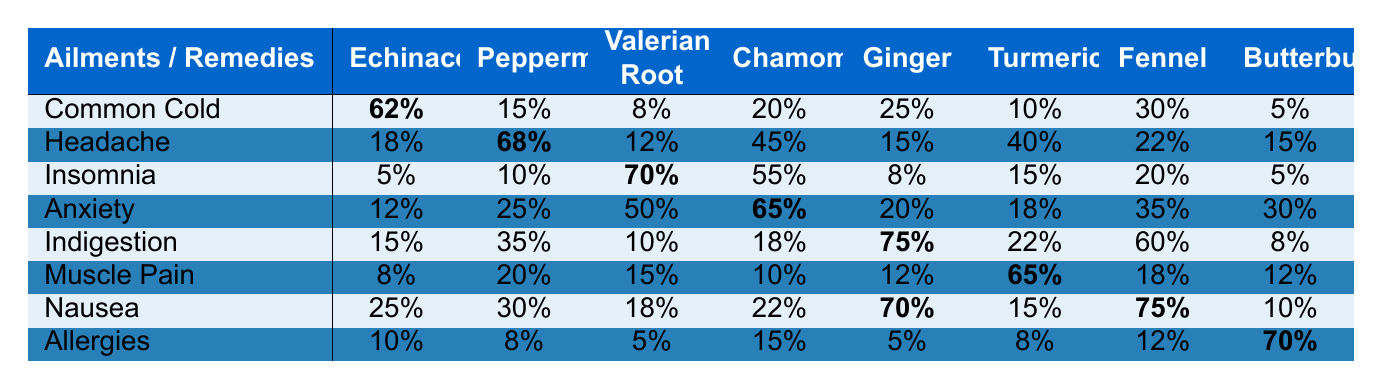What is the efficacy rate of Echinacea for treating the Common Cold? In the row for the Common Cold, under the Echinacea column, the listed efficacy rate is 62%.
Answer: 62% Which herbal remedy has the highest efficacy rate for Insomnia? In the Insomnia row, the Valerian Root has the highest efficacy rate at 70%.
Answer: Valerian Root What is the efficacy rate of Ginger for treating Indigestion? Looking at the row for Indigestion, the efficacy rate for Ginger is 75%.
Answer: 75% Is Chamomile effective for treating Anxiety? In the Anxiety row, Chamomile has an efficacy rate of 65%, which indicates its effectiveness for this ailment.
Answer: Yes What is the average efficacy rate of Turmeric across all ailments? The efficacy rates of Turmeric are 10%, 40%, 15%, 18%, 22%, 65%, 15%, and 8%. Adding these gives 10 + 40 + 15 + 18 + 22 + 65 + 15 + 8 = 193. Dividing by 8 gives an average of 193/8 = 24.125.
Answer: 24.125 Which herbal remedy is most effective for treating Nausea? Looking at the Nausea row, Butterbur has the highest efficacy rate at 75%.
Answer: Butterbur What is the difference in efficacy rates of Valerian Root between Insomnia and Headache? The efficacy rate for Valerian Root is 70% for Insomnia and 12% for Headache. The difference is 70% - 12% = 58%.
Answer: 58% Is the efficacy rate for Fennel in allergies higher than that for Chamomile in Indigestion? Fennel has an efficacy rate of 12% for Allergies and Chamomile has 18% for Indigestion. Since 12% is not higher than 18%, the answer is no.
Answer: No Which herbal remedy shows the lowest efficacy rate overall and what is the ailment? By reviewing each row and column, Butterbur shows a lower efficacy rate with the values of 5%, 15%, 5%, 30%, 8%, 12%, 10%, and 70%. The lowest is 5%, which is for the Common Cold or Insomnia.
Answer: 5% (Common Cold or Insomnia) What is the sum of efficacy rates for all remedies treating Anxiety? Looking at the Anxiety row, the efficacy rates are 12%, 25%, 50%, 65%, 20%, 18%, 35%, and 30%. Summing these values gives 12 + 25 + 50 + 65 + 20 + 18 + 35 + 30 = 255.
Answer: 255 